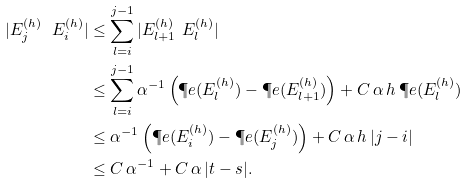Convert formula to latex. <formula><loc_0><loc_0><loc_500><loc_500>| E ^ { ( h ) } _ { j } \ E ^ { ( h ) } _ { i } | & \leq \sum _ { l = i } ^ { j - 1 } | E ^ { ( h ) } _ { l + 1 } \ E ^ { ( h ) } _ { l } | \\ & \leq \sum _ { l = i } ^ { j - 1 } \alpha ^ { - 1 } \left ( \P e ( E ^ { ( h ) } _ { l } ) - \P e ( E ^ { ( h ) } _ { l + 1 } ) \right ) + C \, \alpha \, h \, \P e ( E ^ { ( h ) } _ { l } ) \\ & \leq \alpha ^ { - 1 } \left ( \P e ( E ^ { ( h ) } _ { i } ) - \P e ( E ^ { ( h ) } _ { j } ) \right ) + C \, \alpha \, h \, | j - i | \\ & \leq C \, \alpha ^ { - 1 } + C \, \alpha \, | t - s | .</formula> 